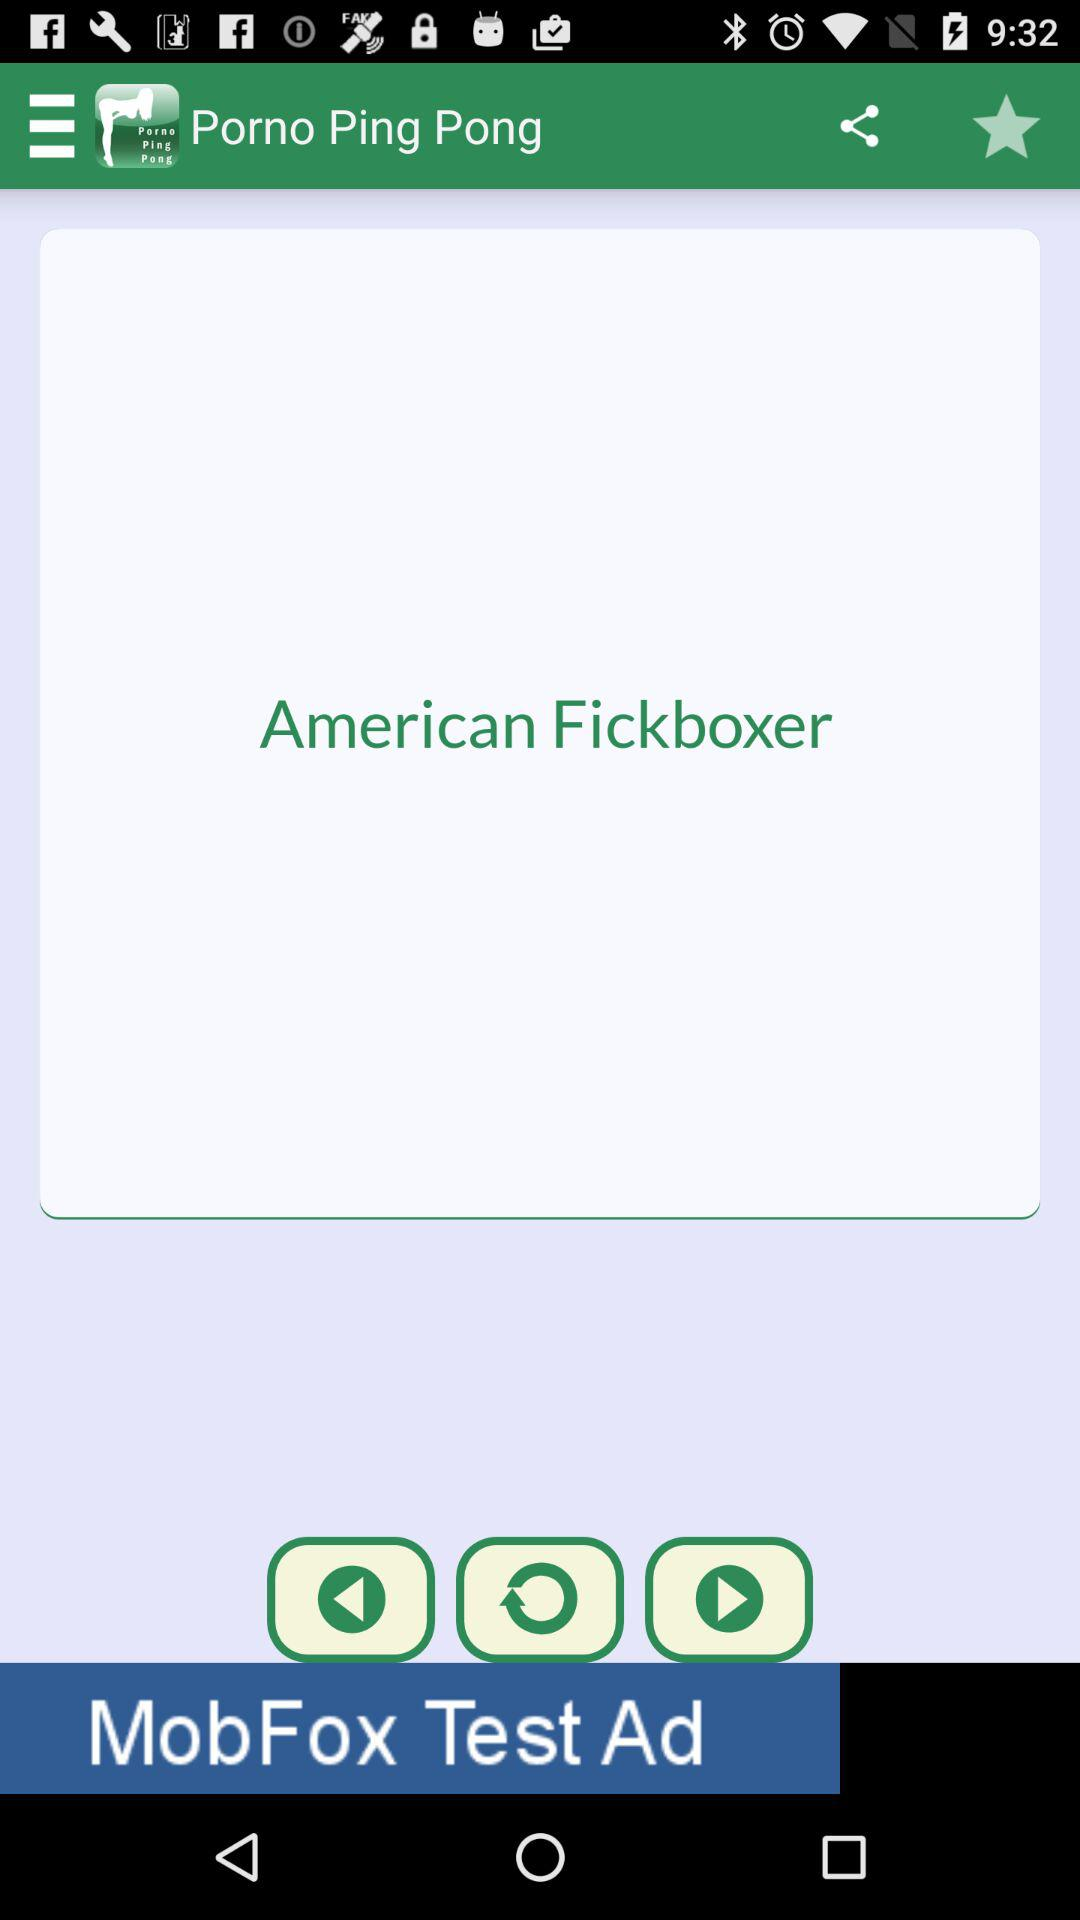What is the name of the application? The name of the application is "Porno Ping Pong". 